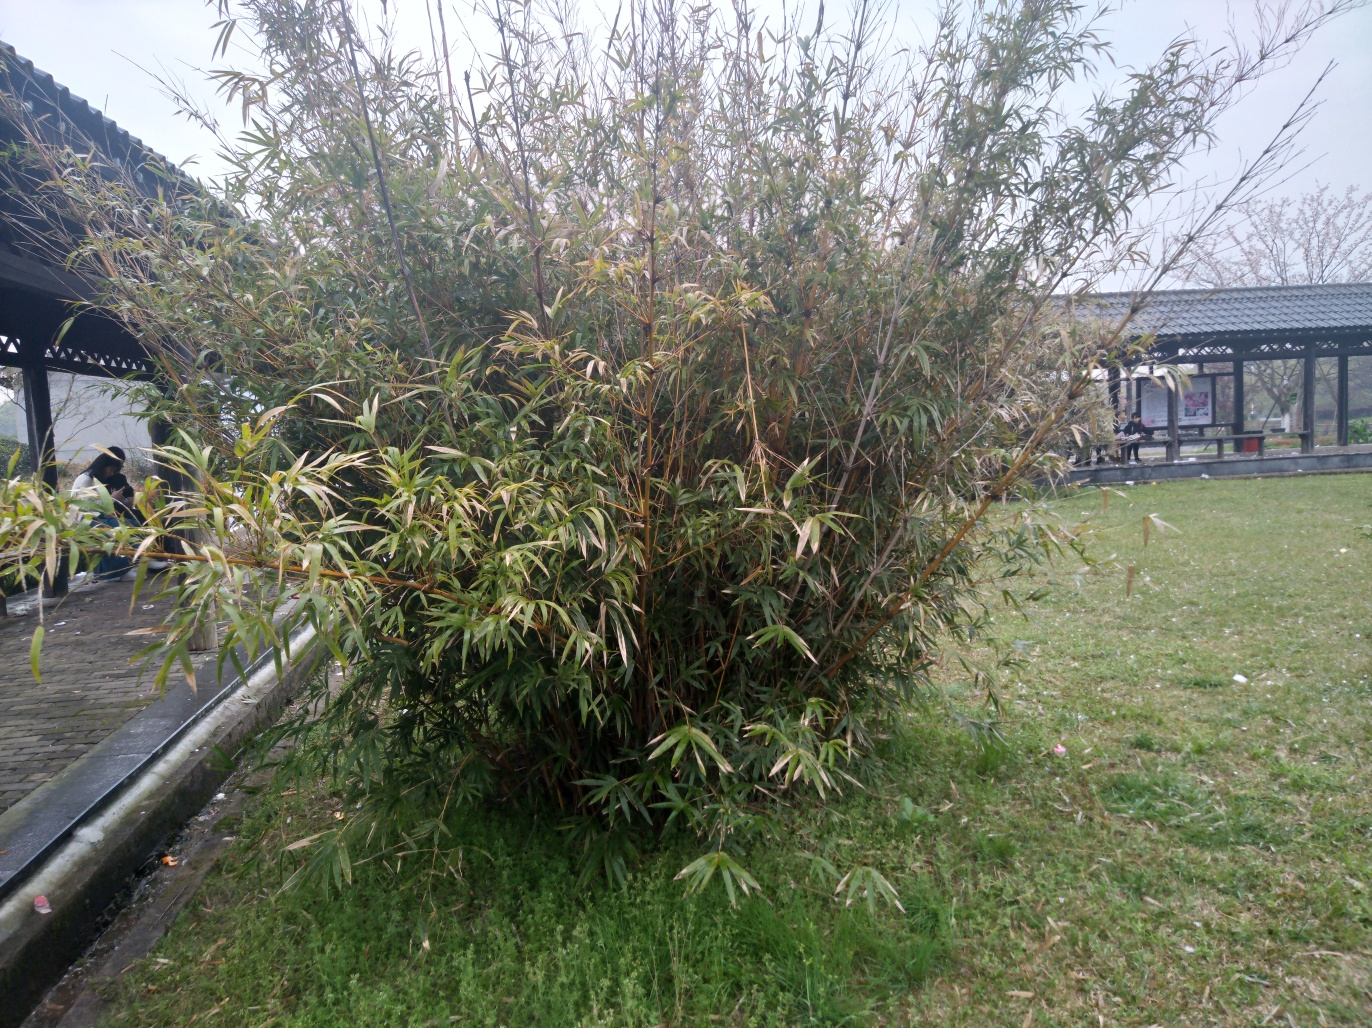Can you tell me more about the type of plant that dominates this image? The plant in the image appears to be a type of bamboo, characterized by its tall, slender stalks and leafy branches. Bamboo is known for its rapid growth and is often found in clusters, forming thickets like the one seen here. It is commonly used in gardens for creating natural screens or as a feature plant. 